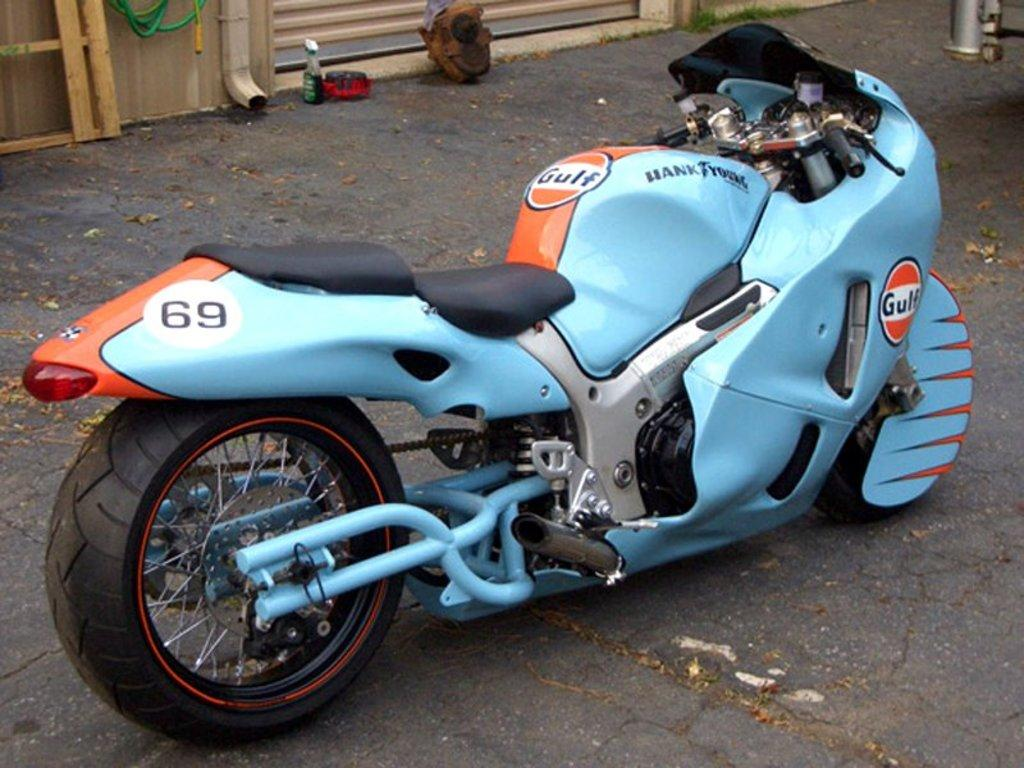What is parked on the road in the image? There is a bike parked on the road in the image. What other object can be seen in the image besides the bike? There is a bottle in the image. What type of structure is visible in the image? There are pipes and a shutter in the image. Can you describe any other objects in the image? There are some other objects in the image, but their specific details are not mentioned in the provided facts. What type of crate is being used to transport the plane in the image? There is no crate or plane present in the image; it only features a bike, a bottle, pipes, and a shutter. 